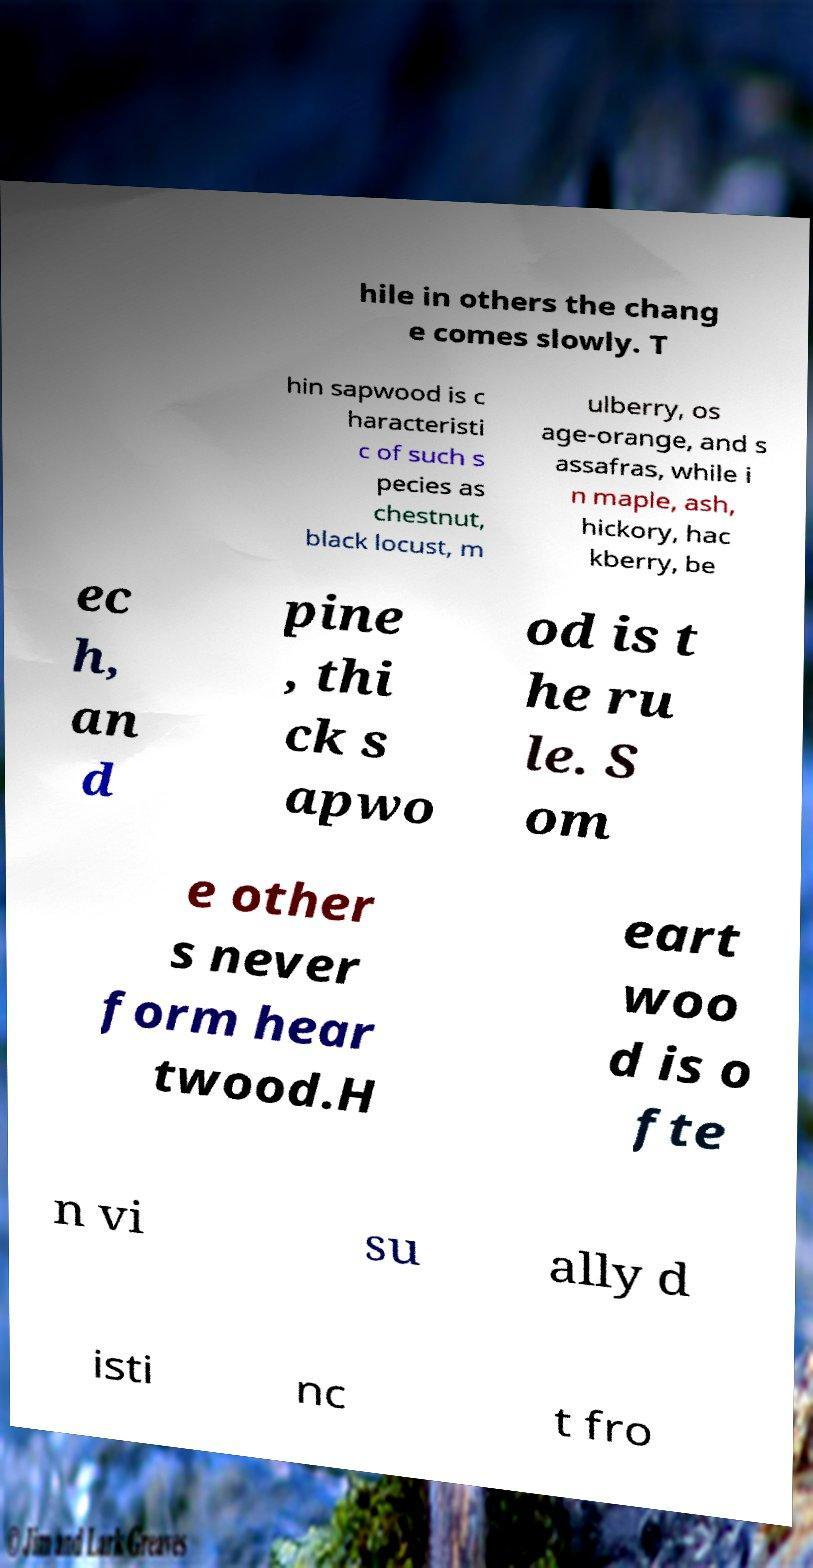For documentation purposes, I need the text within this image transcribed. Could you provide that? hile in others the chang e comes slowly. T hin sapwood is c haracteristi c of such s pecies as chestnut, black locust, m ulberry, os age-orange, and s assafras, while i n maple, ash, hickory, hac kberry, be ec h, an d pine , thi ck s apwo od is t he ru le. S om e other s never form hear twood.H eart woo d is o fte n vi su ally d isti nc t fro 